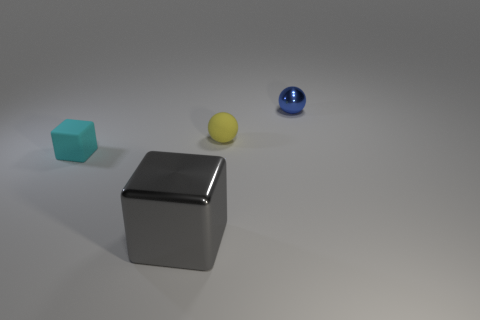What is the material of the object that is both on the right side of the tiny cyan rubber object and on the left side of the rubber ball?
Ensure brevity in your answer.  Metal. The gray metallic cube is what size?
Give a very brief answer. Large. The other thing that is the same shape as the blue metal thing is what color?
Keep it short and to the point. Yellow. Are there any other things that have the same color as the metal sphere?
Ensure brevity in your answer.  No. Is the size of the shiny object that is behind the cyan object the same as the object in front of the tiny cyan matte thing?
Your answer should be very brief. No. Are there an equal number of metal cubes left of the gray block and spheres in front of the small yellow matte sphere?
Provide a short and direct response. Yes. Is the size of the yellow object the same as the thing in front of the tiny cyan rubber thing?
Provide a short and direct response. No. Are there any gray objects right of the cube left of the big gray thing?
Give a very brief answer. Yes. Is there a gray metallic thing of the same shape as the cyan thing?
Provide a succinct answer. Yes. What number of large gray shiny blocks are in front of the tiny rubber object on the left side of the large block left of the blue metal sphere?
Give a very brief answer. 1. 